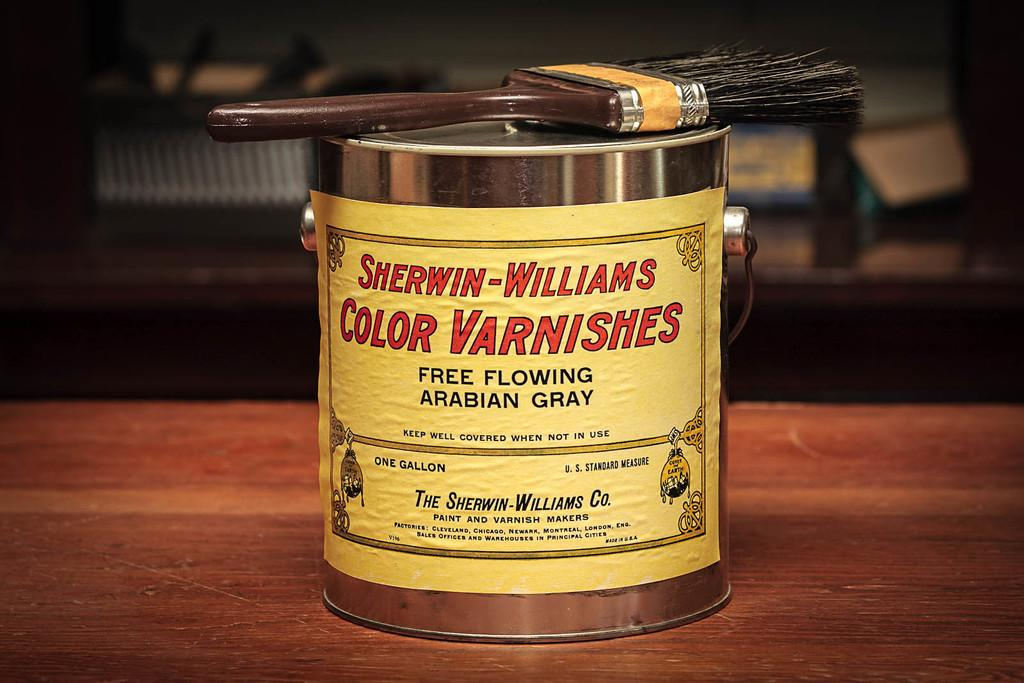<image>
Summarize the visual content of the image. A can of Sherwin-Williams color varnishes in Arabian gray. 